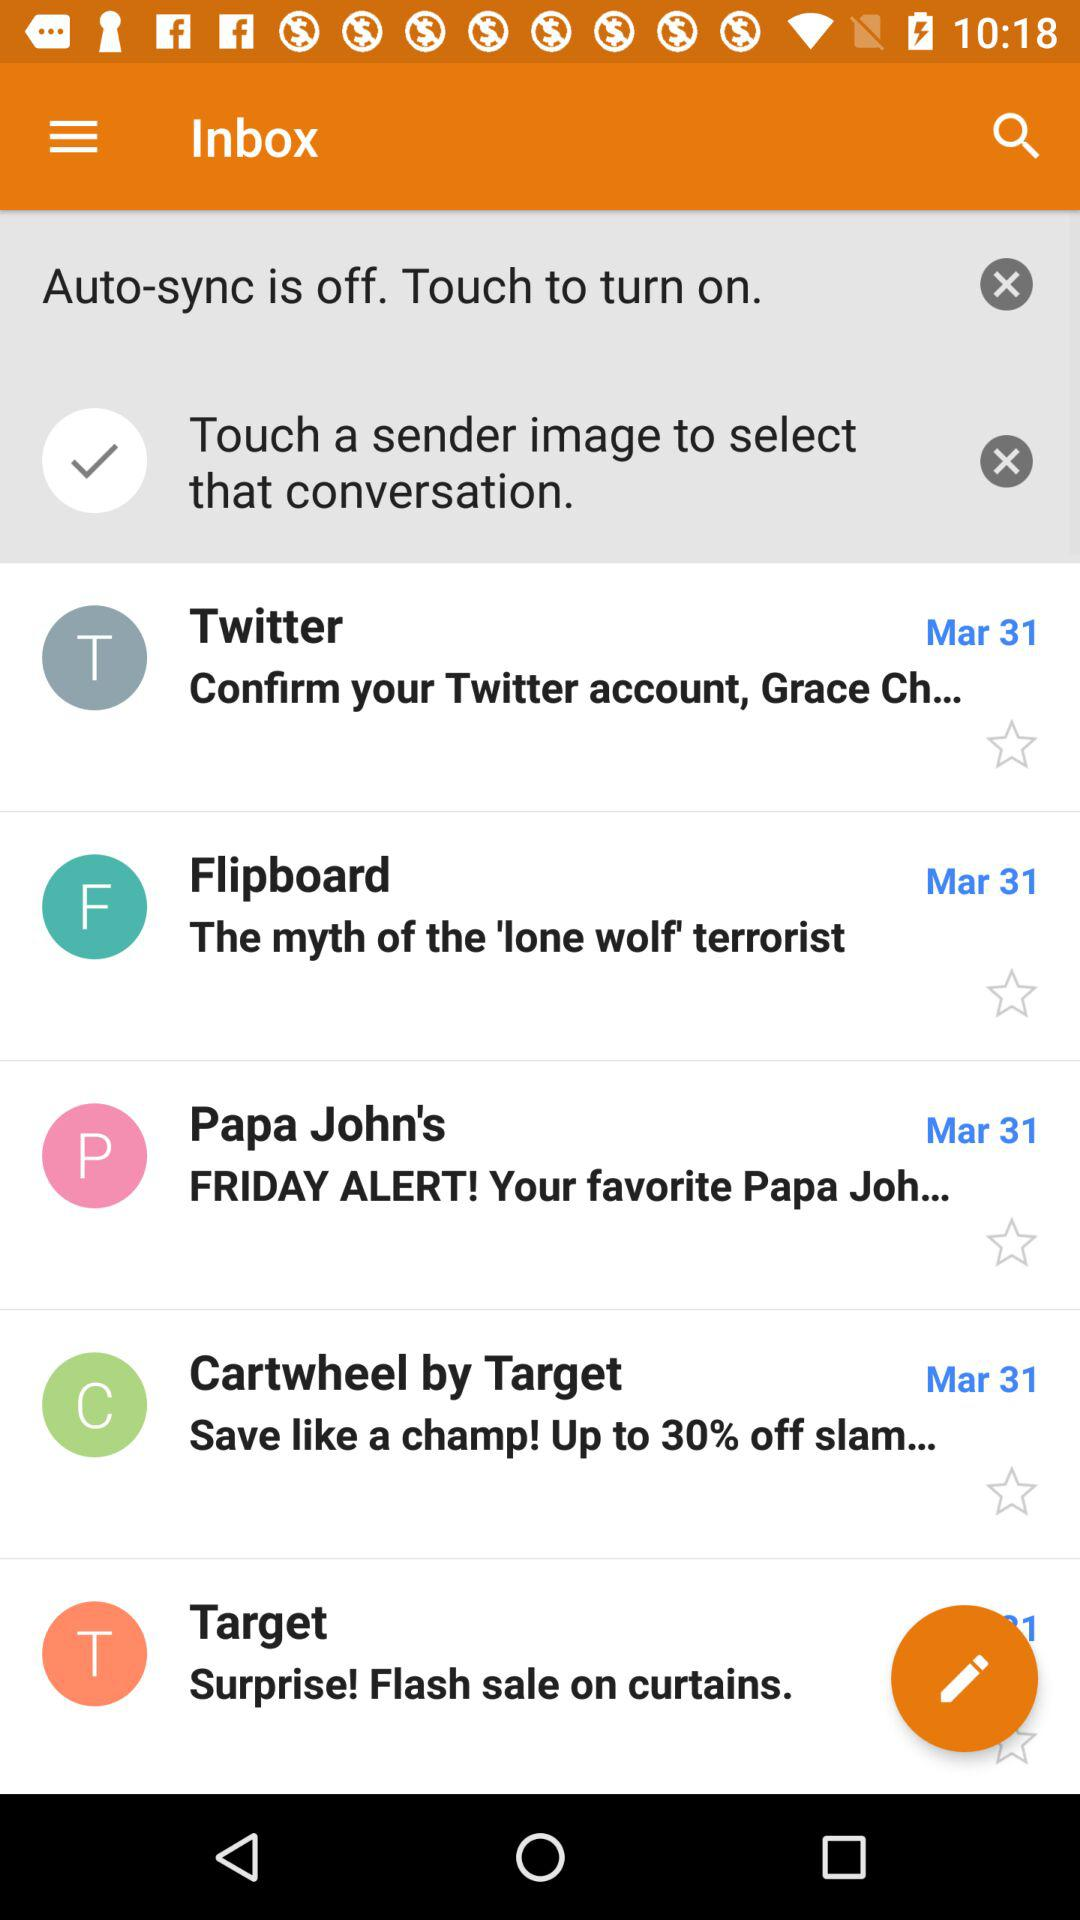On what date did the Twitter message come? The message comes on March 31. 